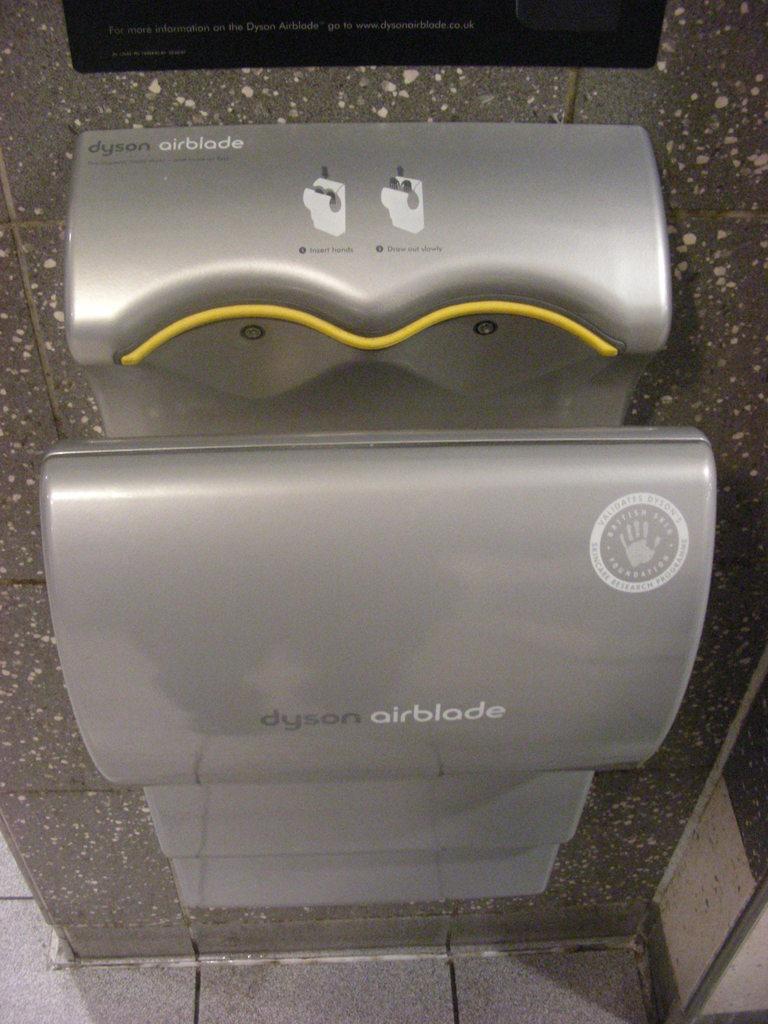Is step 1 to insert your hands?
Your answer should be compact. Yes. What is the brand of hand dryer shown here called?
Provide a short and direct response. Dyson. 